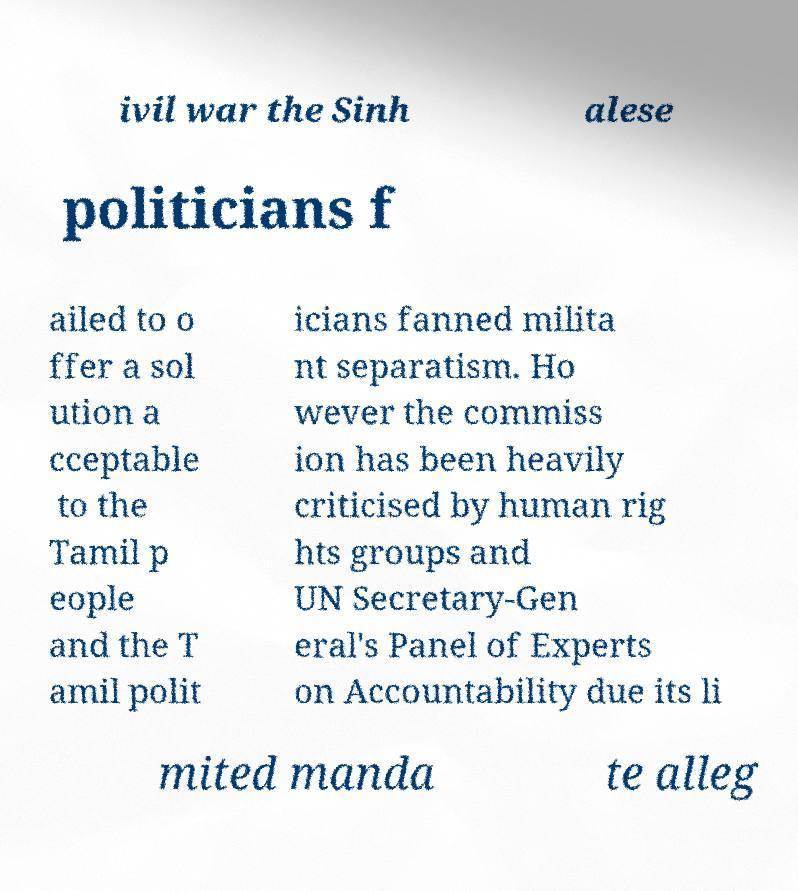Could you extract and type out the text from this image? ivil war the Sinh alese politicians f ailed to o ffer a sol ution a cceptable to the Tamil p eople and the T amil polit icians fanned milita nt separatism. Ho wever the commiss ion has been heavily criticised by human rig hts groups and UN Secretary-Gen eral's Panel of Experts on Accountability due its li mited manda te alleg 